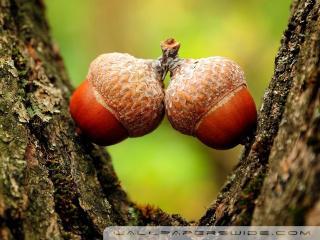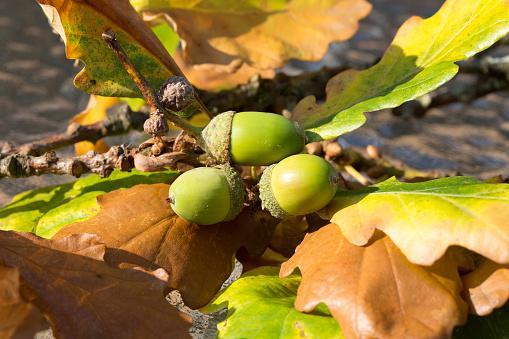The first image is the image on the left, the second image is the image on the right. For the images shown, is this caption "The acorns in one of the images are green, while the acorns in the other image are brown." true? Answer yes or no. Yes. The first image is the image on the left, the second image is the image on the right. Examine the images to the left and right. Is the description "There are five real acorns." accurate? Answer yes or no. Yes. 